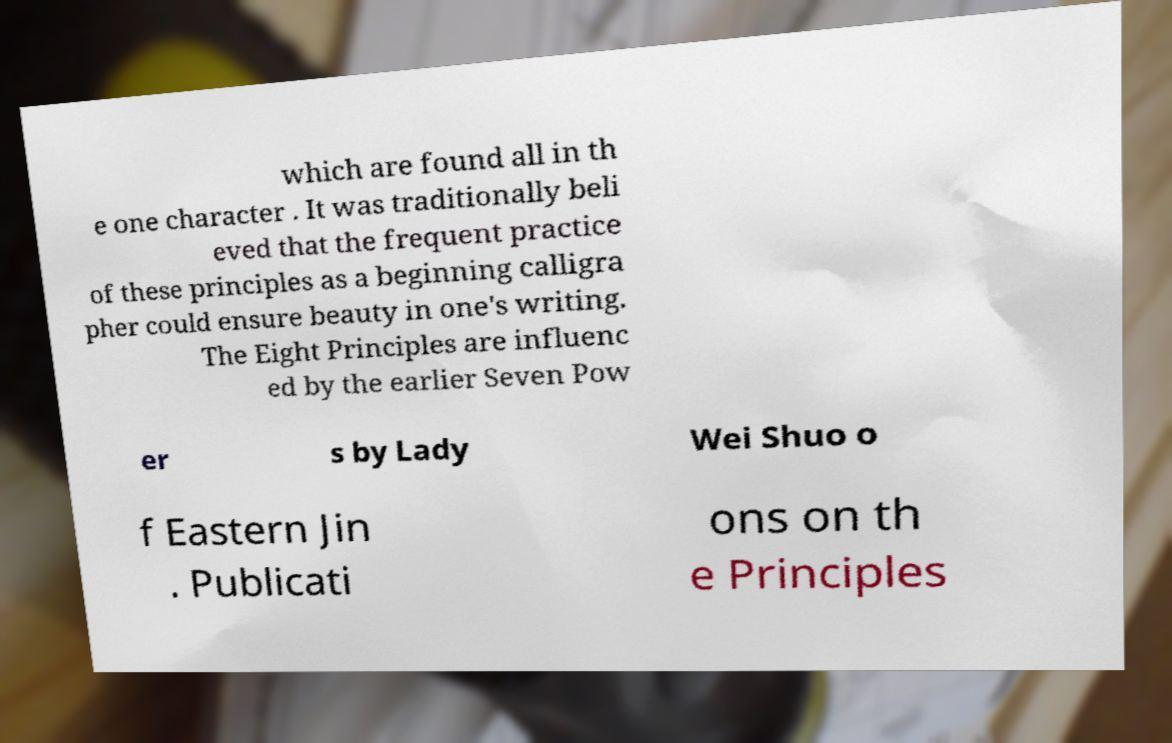Could you extract and type out the text from this image? which are found all in th e one character . It was traditionally beli eved that the frequent practice of these principles as a beginning calligra pher could ensure beauty in one's writing. The Eight Principles are influenc ed by the earlier Seven Pow er s by Lady Wei Shuo o f Eastern Jin . Publicati ons on th e Principles 